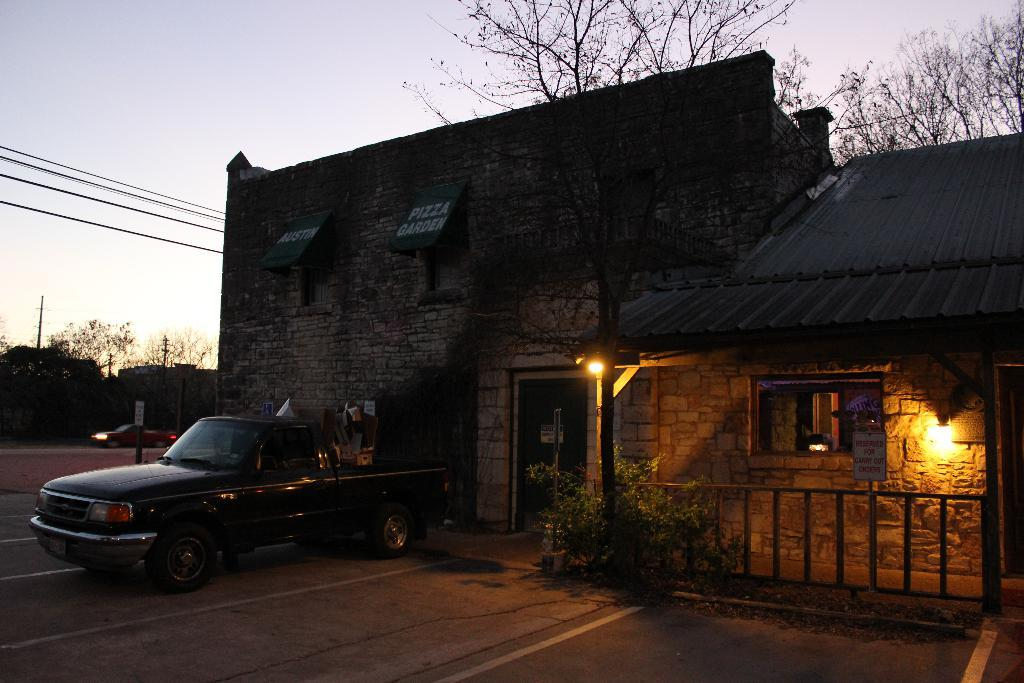What type of building is in the picture? There is a house in the picture. What other natural elements can be seen in the picture? There are trees in the picture. What feature is located on the right side of the picture? There is a railing on the right side of the picture. What mode of transportation is parked near the house? A car is parked in front of the house. What is visible in the background of the picture? The sky is visible in the background of the picture. How does the heat affect the car's performance in the picture? There is no indication of heat or temperature in the picture, so it cannot be determined how it affects the car's performance. 